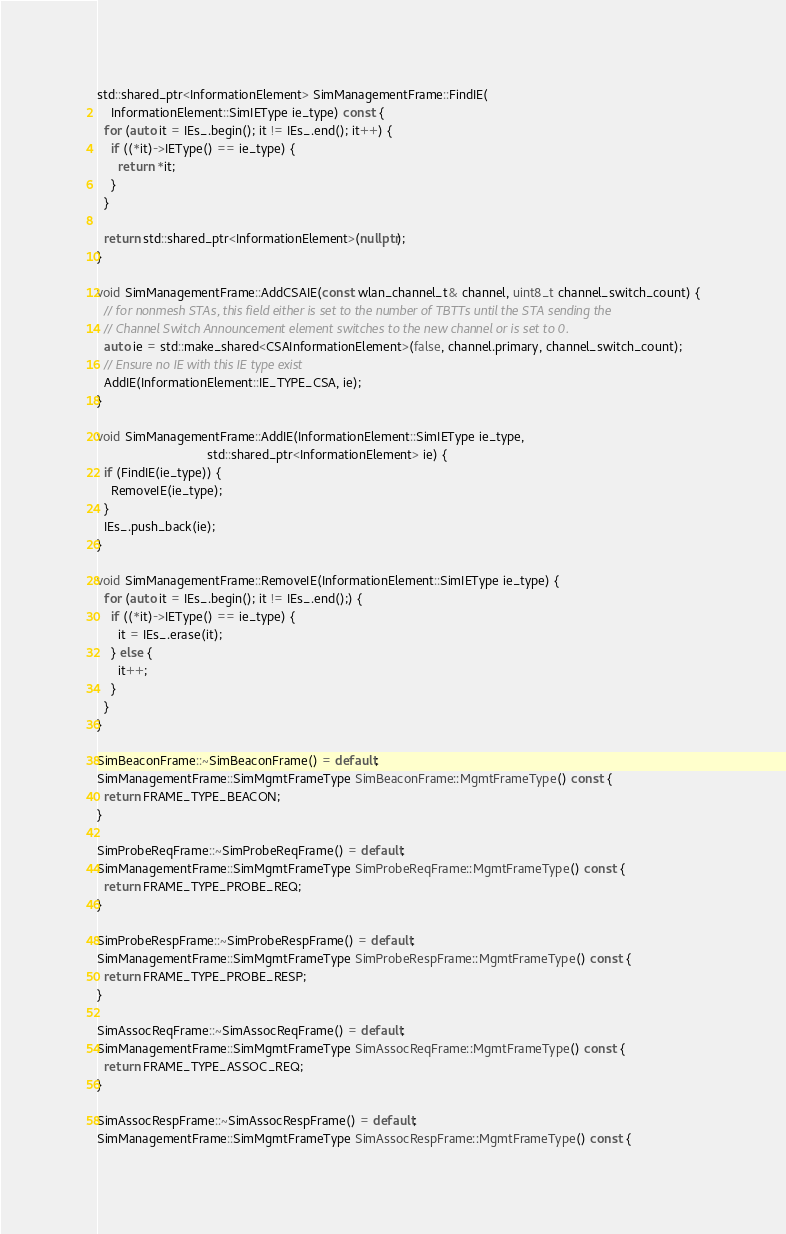<code> <loc_0><loc_0><loc_500><loc_500><_C++_>
std::shared_ptr<InformationElement> SimManagementFrame::FindIE(
    InformationElement::SimIEType ie_type) const {
  for (auto it = IEs_.begin(); it != IEs_.end(); it++) {
    if ((*it)->IEType() == ie_type) {
      return *it;
    }
  }

  return std::shared_ptr<InformationElement>(nullptr);
}

void SimManagementFrame::AddCSAIE(const wlan_channel_t& channel, uint8_t channel_switch_count) {
  // for nonmesh STAs, this field either is set to the number of TBTTs until the STA sending the
  // Channel Switch Announcement element switches to the new channel or is set to 0.
  auto ie = std::make_shared<CSAInformationElement>(false, channel.primary, channel_switch_count);
  // Ensure no IE with this IE type exist
  AddIE(InformationElement::IE_TYPE_CSA, ie);
}

void SimManagementFrame::AddIE(InformationElement::SimIEType ie_type,
                               std::shared_ptr<InformationElement> ie) {
  if (FindIE(ie_type)) {
    RemoveIE(ie_type);
  }
  IEs_.push_back(ie);
}

void SimManagementFrame::RemoveIE(InformationElement::SimIEType ie_type) {
  for (auto it = IEs_.begin(); it != IEs_.end();) {
    if ((*it)->IEType() == ie_type) {
      it = IEs_.erase(it);
    } else {
      it++;
    }
  }
}

SimBeaconFrame::~SimBeaconFrame() = default;
SimManagementFrame::SimMgmtFrameType SimBeaconFrame::MgmtFrameType() const {
  return FRAME_TYPE_BEACON;
}

SimProbeReqFrame::~SimProbeReqFrame() = default;
SimManagementFrame::SimMgmtFrameType SimProbeReqFrame::MgmtFrameType() const {
  return FRAME_TYPE_PROBE_REQ;
}

SimProbeRespFrame::~SimProbeRespFrame() = default;
SimManagementFrame::SimMgmtFrameType SimProbeRespFrame::MgmtFrameType() const {
  return FRAME_TYPE_PROBE_RESP;
}

SimAssocReqFrame::~SimAssocReqFrame() = default;
SimManagementFrame::SimMgmtFrameType SimAssocReqFrame::MgmtFrameType() const {
  return FRAME_TYPE_ASSOC_REQ;
}

SimAssocRespFrame::~SimAssocRespFrame() = default;
SimManagementFrame::SimMgmtFrameType SimAssocRespFrame::MgmtFrameType() const {</code> 